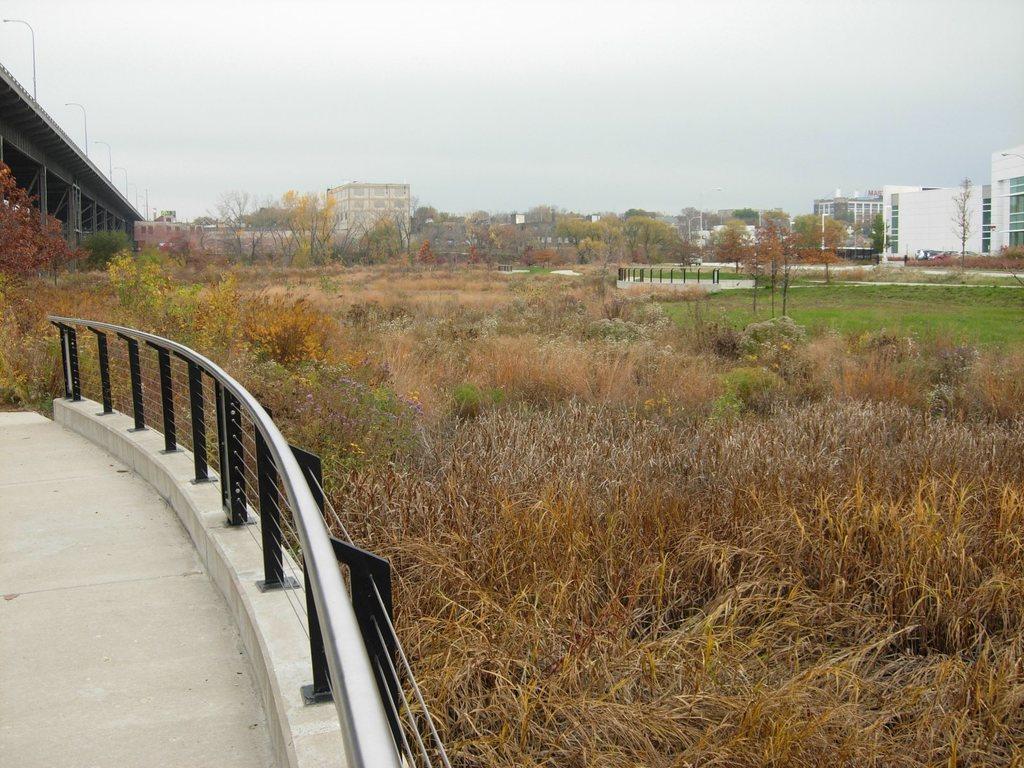Please provide a concise description of this image. In the picture here I can see the steel railing, dry grass, bridge on the left side of the image, we can see grass, trees, buildings and the sky in the background. 